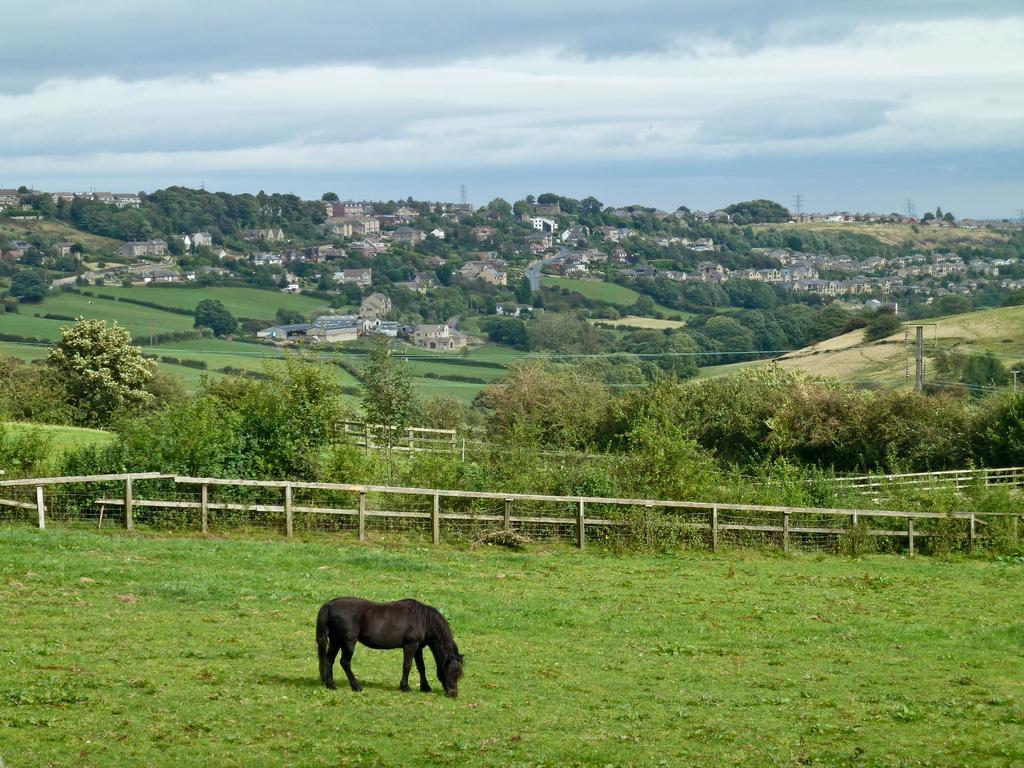Could you give a brief overview of what you see in this image? This picture is taken from the outside of the city. In this image, in the middle, we can see a horse eating grass. In the background, we can see wood fence, trees, plants. In the background, we can also see some houses, building, trees, plants, electric pole. At the top, we can see a sky which is cloudy, at the bottom, we can see some plants and a grass. 